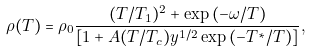<formula> <loc_0><loc_0><loc_500><loc_500>\rho ( T ) = \rho _ { 0 } \frac { ( T / T _ { 1 } ) ^ { 2 } + \exp \left ( - \omega / T \right ) } { [ 1 + A ( T / T _ { c } ) y ^ { 1 / 2 } \exp \left ( - T ^ { \ast } / T \right ) ] } ,</formula> 